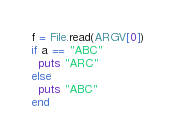Convert code to text. <code><loc_0><loc_0><loc_500><loc_500><_Ruby_>f = File.read(ARGV[0])
if a == "ABC"
  puts "ARC"
else
  puts "ABC"
end</code> 